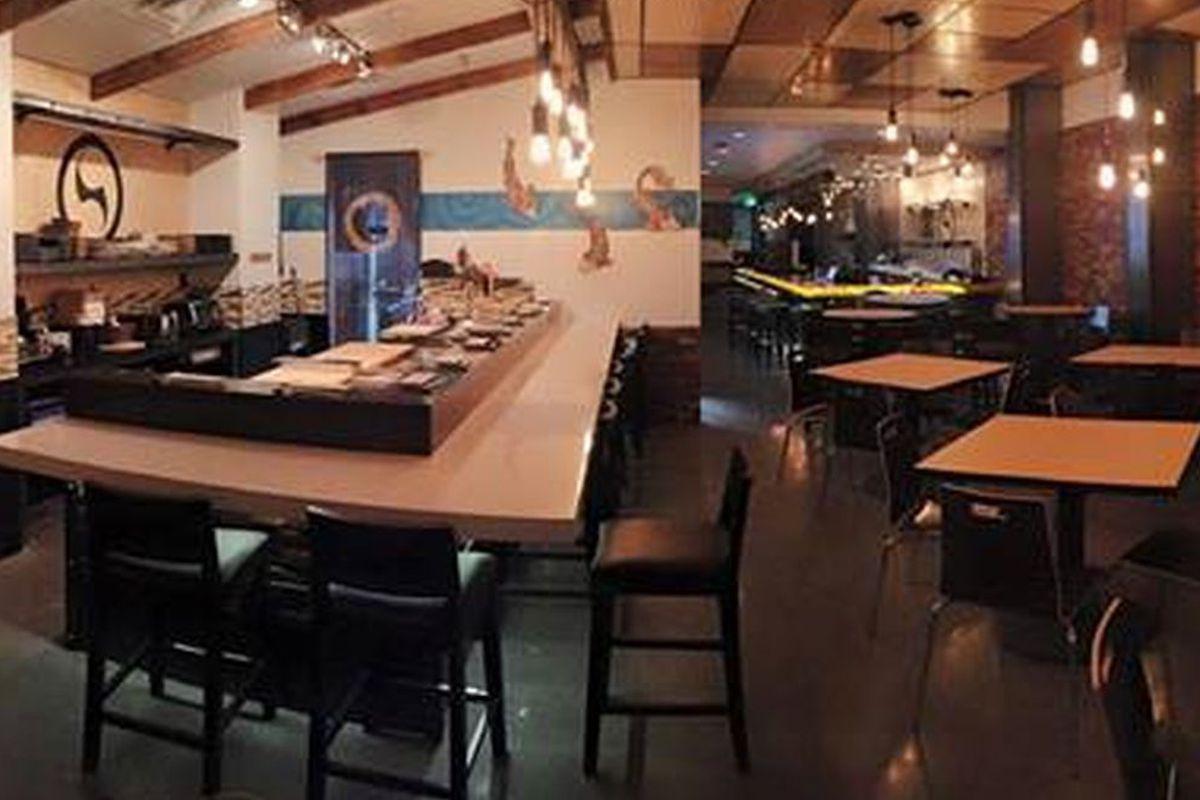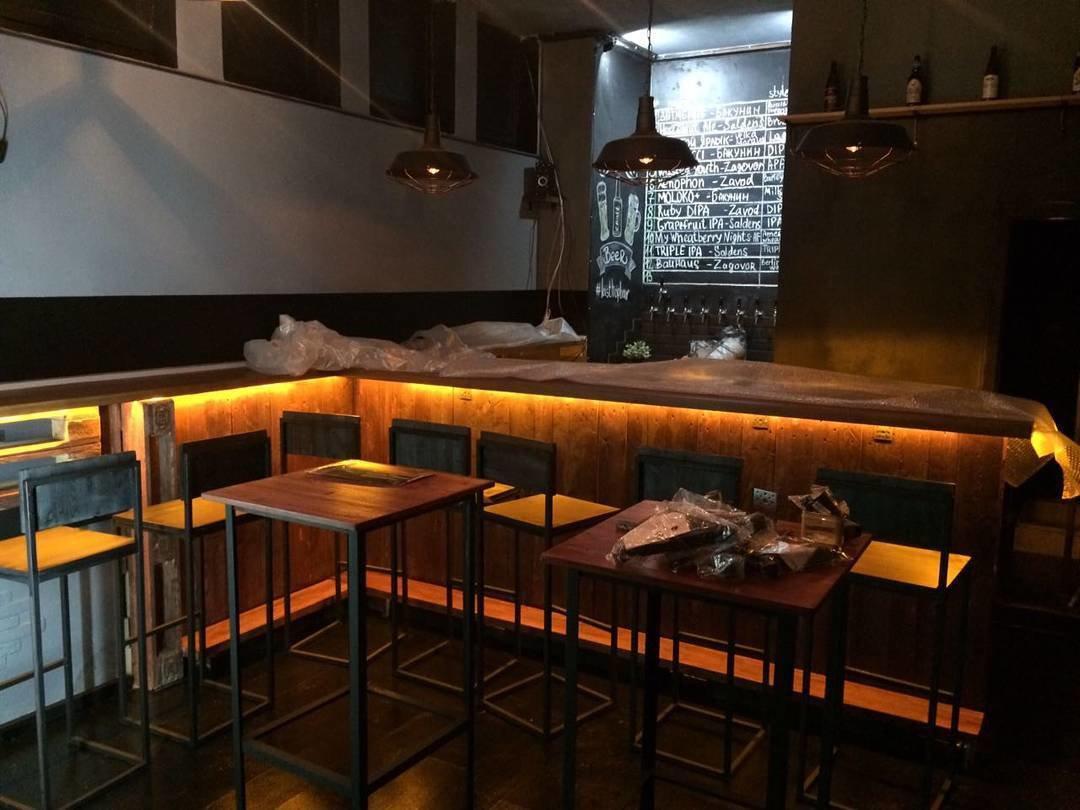The first image is the image on the left, the second image is the image on the right. For the images displayed, is the sentence "In at least one image there is a single long bar with at least two black hanging lights over it." factually correct? Answer yes or no. Yes. 